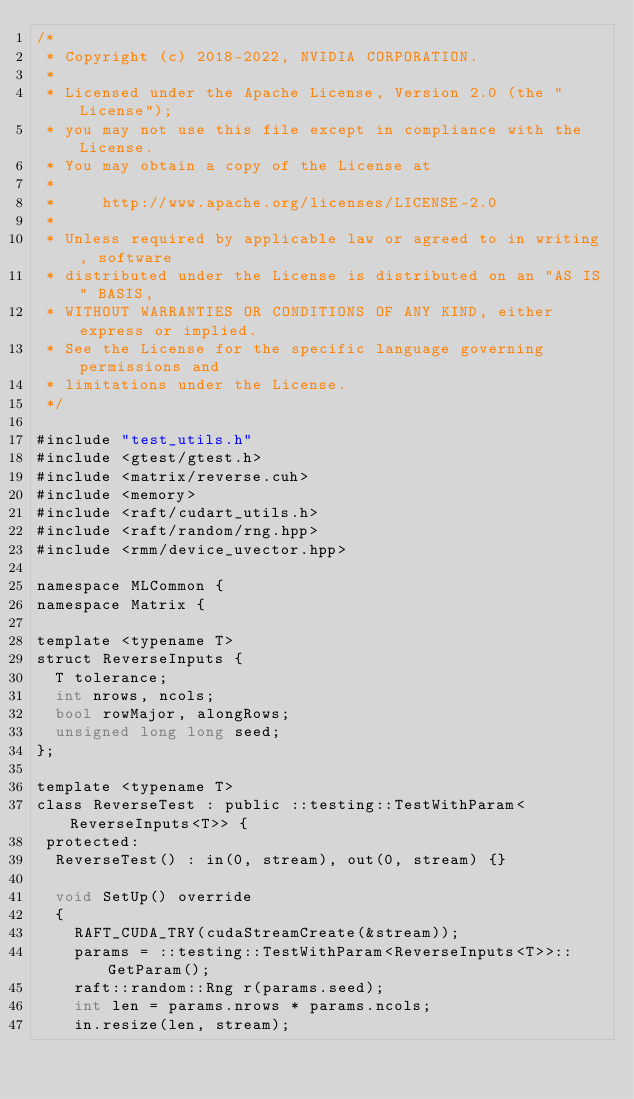Convert code to text. <code><loc_0><loc_0><loc_500><loc_500><_Cuda_>/*
 * Copyright (c) 2018-2022, NVIDIA CORPORATION.
 *
 * Licensed under the Apache License, Version 2.0 (the "License");
 * you may not use this file except in compliance with the License.
 * You may obtain a copy of the License at
 *
 *     http://www.apache.org/licenses/LICENSE-2.0
 *
 * Unless required by applicable law or agreed to in writing, software
 * distributed under the License is distributed on an "AS IS" BASIS,
 * WITHOUT WARRANTIES OR CONDITIONS OF ANY KIND, either express or implied.
 * See the License for the specific language governing permissions and
 * limitations under the License.
 */

#include "test_utils.h"
#include <gtest/gtest.h>
#include <matrix/reverse.cuh>
#include <memory>
#include <raft/cudart_utils.h>
#include <raft/random/rng.hpp>
#include <rmm/device_uvector.hpp>

namespace MLCommon {
namespace Matrix {

template <typename T>
struct ReverseInputs {
  T tolerance;
  int nrows, ncols;
  bool rowMajor, alongRows;
  unsigned long long seed;
};

template <typename T>
class ReverseTest : public ::testing::TestWithParam<ReverseInputs<T>> {
 protected:
  ReverseTest() : in(0, stream), out(0, stream) {}

  void SetUp() override
  {
    RAFT_CUDA_TRY(cudaStreamCreate(&stream));
    params = ::testing::TestWithParam<ReverseInputs<T>>::GetParam();
    raft::random::Rng r(params.seed);
    int len = params.nrows * params.ncols;
    in.resize(len, stream);</code> 